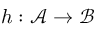Convert formula to latex. <formula><loc_0><loc_0><loc_500><loc_500>h \colon { \mathcal { A } } \rightarrow { \mathcal { B } }</formula> 